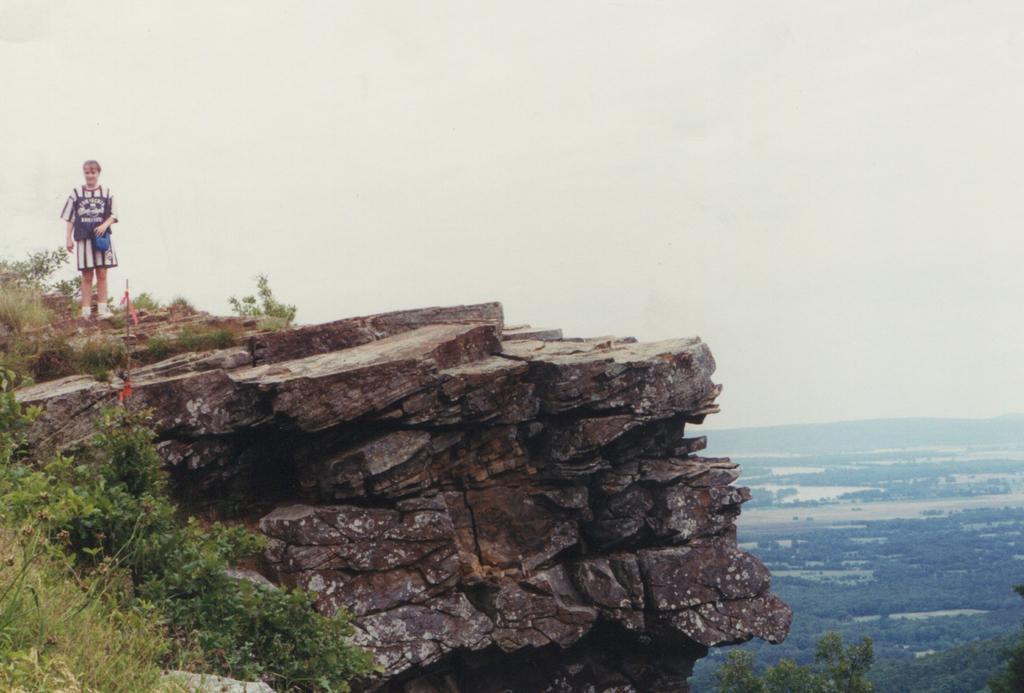Describe this image in one or two sentences. In the image I can see a hill on which there is a person and also I can see some plants and the view of a place where we have some trees, plants and water. 